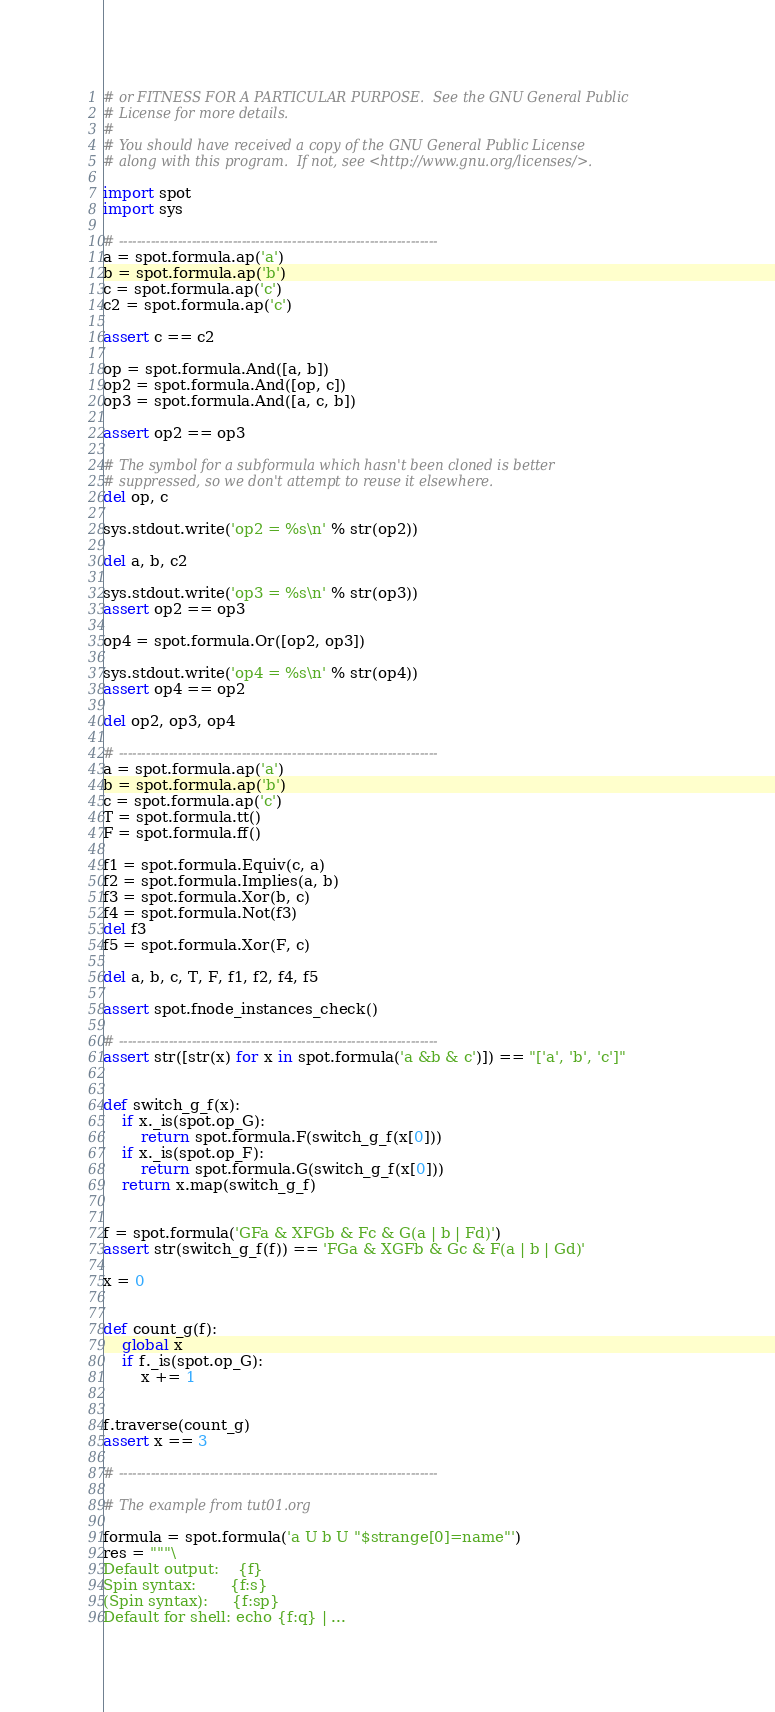Convert code to text. <code><loc_0><loc_0><loc_500><loc_500><_Python_># or FITNESS FOR A PARTICULAR PURPOSE.  See the GNU General Public
# License for more details.
#
# You should have received a copy of the GNU General Public License
# along with this program.  If not, see <http://www.gnu.org/licenses/>.

import spot
import sys

# ----------------------------------------------------------------------
a = spot.formula.ap('a')
b = spot.formula.ap('b')
c = spot.formula.ap('c')
c2 = spot.formula.ap('c')

assert c == c2

op = spot.formula.And([a, b])
op2 = spot.formula.And([op, c])
op3 = spot.formula.And([a, c, b])

assert op2 == op3

# The symbol for a subformula which hasn't been cloned is better
# suppressed, so we don't attempt to reuse it elsewhere.
del op, c

sys.stdout.write('op2 = %s\n' % str(op2))

del a, b, c2

sys.stdout.write('op3 = %s\n' % str(op3))
assert op2 == op3

op4 = spot.formula.Or([op2, op3])

sys.stdout.write('op4 = %s\n' % str(op4))
assert op4 == op2

del op2, op3, op4

# ----------------------------------------------------------------------
a = spot.formula.ap('a')
b = spot.formula.ap('b')
c = spot.formula.ap('c')
T = spot.formula.tt()
F = spot.formula.ff()

f1 = spot.formula.Equiv(c, a)
f2 = spot.formula.Implies(a, b)
f3 = spot.formula.Xor(b, c)
f4 = spot.formula.Not(f3)
del f3
f5 = spot.formula.Xor(F, c)

del a, b, c, T, F, f1, f2, f4, f5

assert spot.fnode_instances_check()

# ----------------------------------------------------------------------
assert str([str(x) for x in spot.formula('a &b & c')]) == "['a', 'b', 'c']"


def switch_g_f(x):
    if x._is(spot.op_G):
        return spot.formula.F(switch_g_f(x[0]))
    if x._is(spot.op_F):
        return spot.formula.G(switch_g_f(x[0]))
    return x.map(switch_g_f)


f = spot.formula('GFa & XFGb & Fc & G(a | b | Fd)')
assert str(switch_g_f(f)) == 'FGa & XGFb & Gc & F(a | b | Gd)'

x = 0


def count_g(f):
    global x
    if f._is(spot.op_G):
        x += 1


f.traverse(count_g)
assert x == 3

# ----------------------------------------------------------------------

# The example from tut01.org

formula = spot.formula('a U b U "$strange[0]=name"')
res = """\
Default output:    {f}
Spin syntax:       {f:s}
(Spin syntax):     {f:sp}
Default for shell: echo {f:q} | ...</code> 